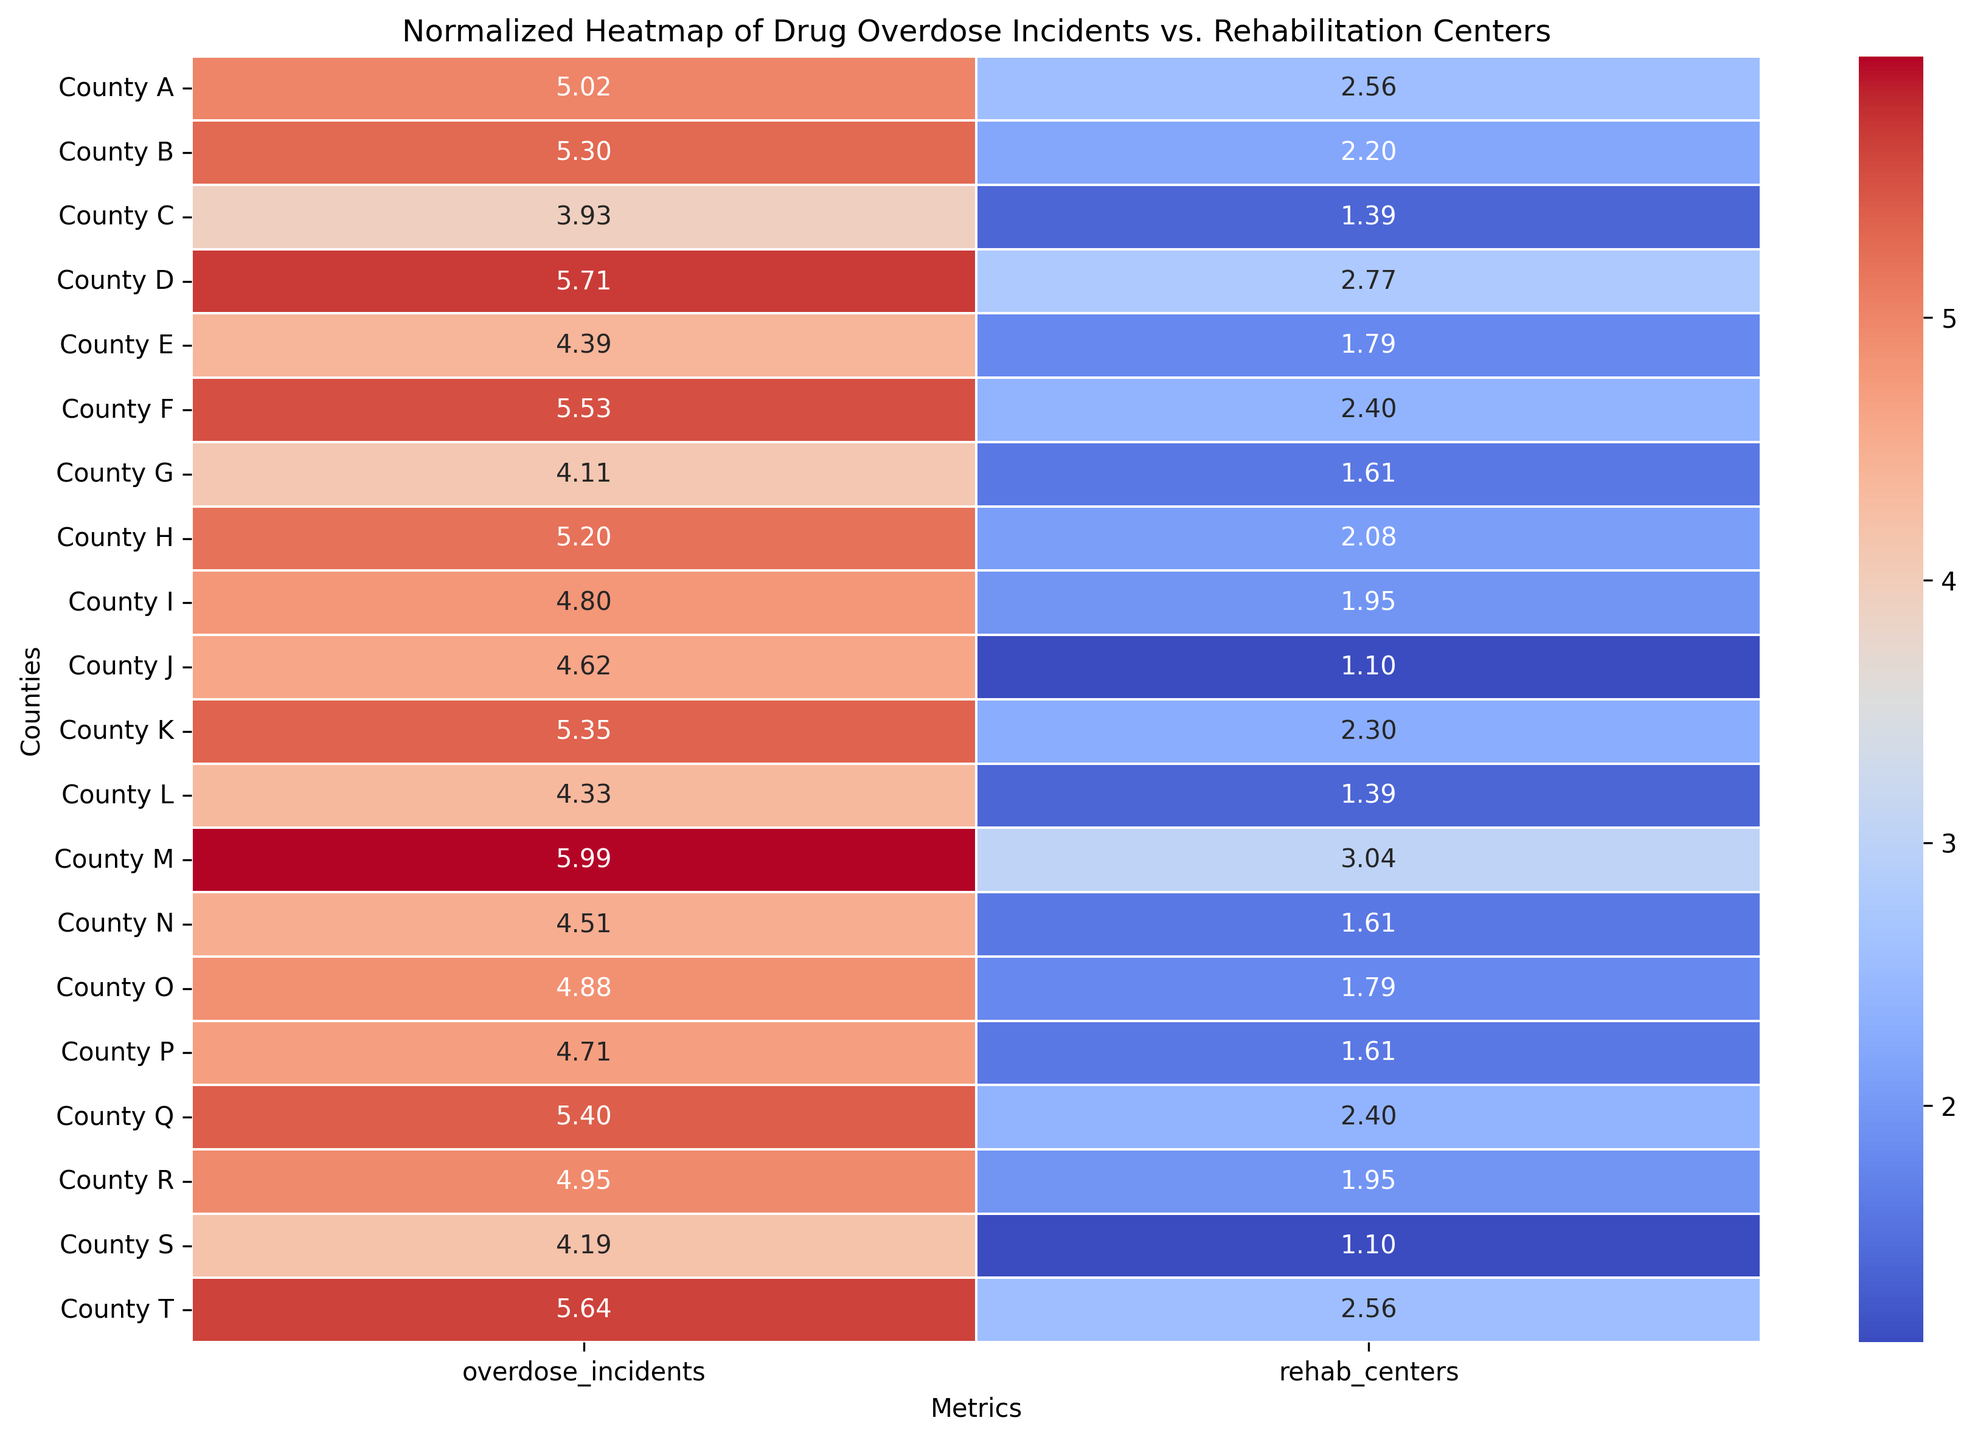Which county has the highest normalized value for drug overdose incidents? Examine the heatmap for the county with the darkest red in the overdose incidents column. County M has the highest value.
Answer: County M Which county has the least number of rehabilitation centers after normalization? Look for the lightest shade of blue in the rehab centers column. County J and County S have the lightest shades with the lowest values.
Answer: County J, County S Which counties have more than 200 overdose incidents and fewer than 10 rehab centers? Check the heatmap for counties with a higher intensity in the overdose incidents column and a lighter shade in the rehab centers column. Counties B, F, and K meet these criteria.
Answer: County B, County F, County K What is the average normalized value for rehab centers across all counties? Examine the normalized values annotated in the heatmap for the rehab centers and calculate their average. Sum the normalized values and divide by the number of counties (20).
Answer: (Average needs calculation) Which county has the closest normalized values for both overdose incidents and rehab centers? Look for the county where normalized values of both metrics are numerically closest in the heatmap. County T appears to have similar normalized values for both metrics.
Answer: County T Between counties D and T, which has a higher normalized value for overdose incidents? Compare the red intensity between counties D and T in the overdose incidents column. County D has a higher normalized value.
Answer: County D What is the sum of normalized values for rehab centers in counties with more than 150 overdose incidents? Identify counties with overdose incidents > 150 using color intensity in the overdose incidents column and sum their normalized rehab center values.
Answer: (Sum needs calculation) Which county has the greatest difference between normalized overdose incidents and rehab centers values? Calculate the absolute difference between the normalized values in both columns for all counties; the largest difference indicates the answer. County M shows a large disparity.
Answer: County M 